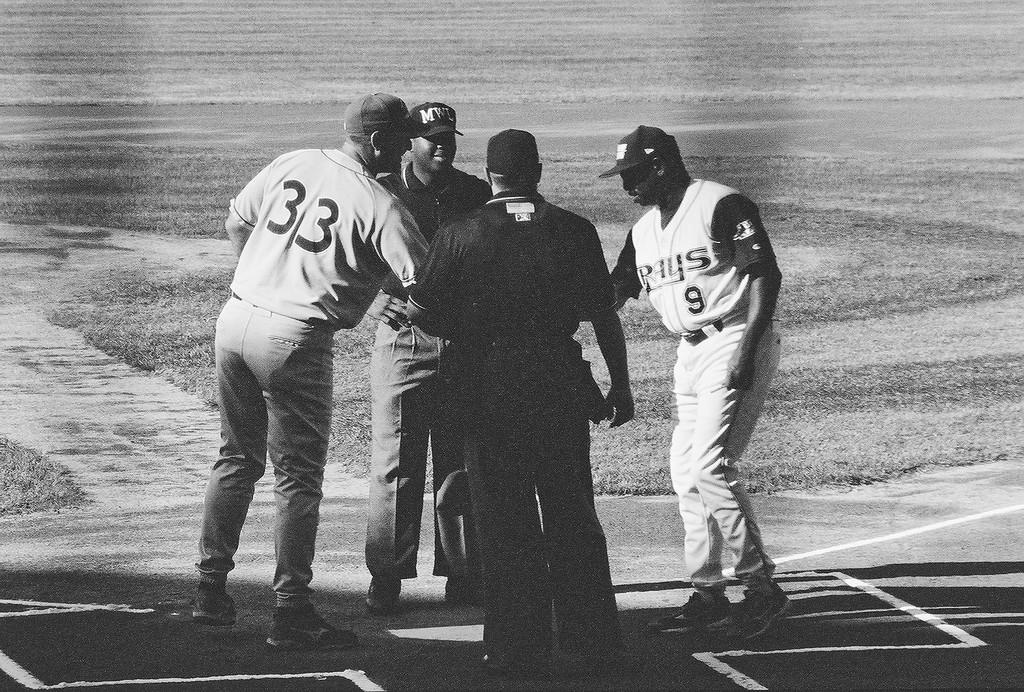<image>
Give a short and clear explanation of the subsequent image. A man in a number 33 jersey shakes hands over home plate with a Rays player 